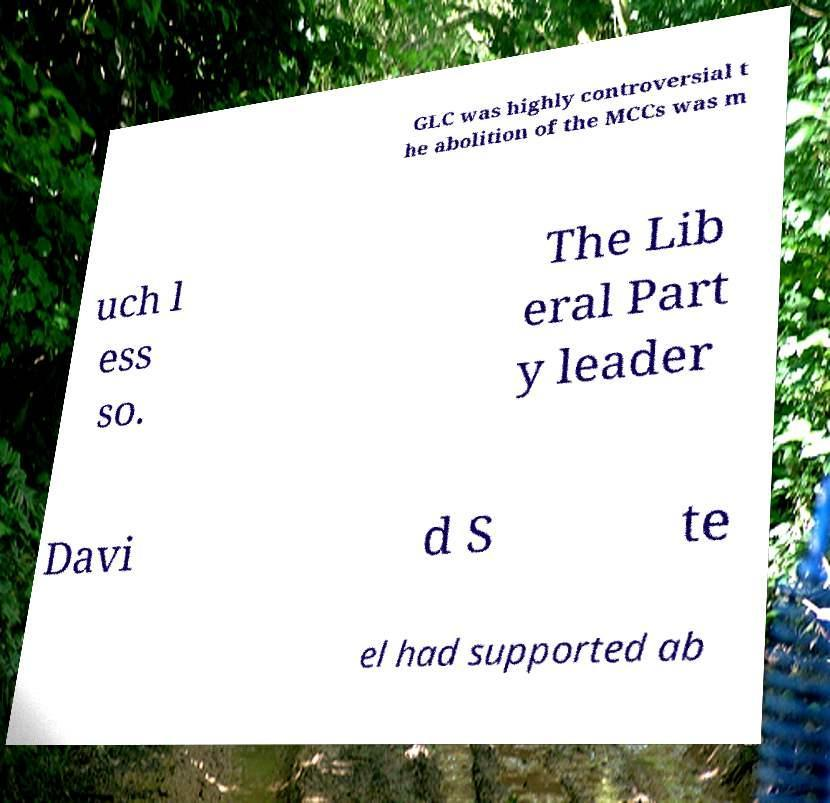Could you extract and type out the text from this image? GLC was highly controversial t he abolition of the MCCs was m uch l ess so. The Lib eral Part y leader Davi d S te el had supported ab 